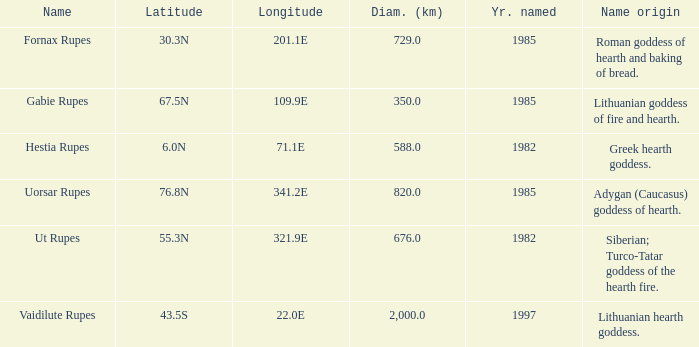At a longitude of 109.9e, how many features were found? 1.0. 